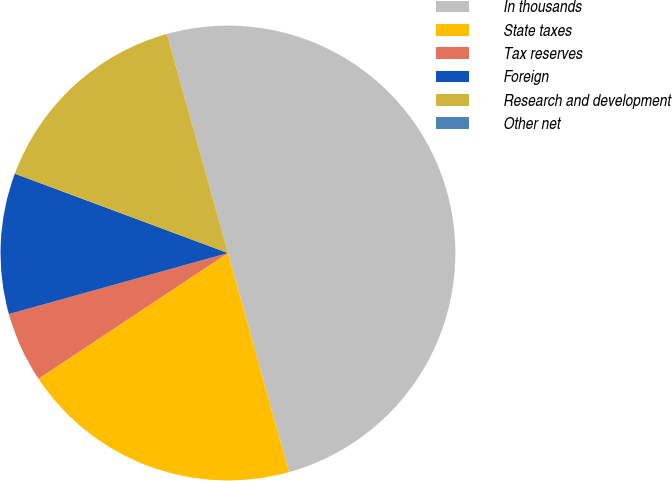Convert chart. <chart><loc_0><loc_0><loc_500><loc_500><pie_chart><fcel>In thousands<fcel>State taxes<fcel>Tax reserves<fcel>Foreign<fcel>Research and development<fcel>Other net<nl><fcel>50.0%<fcel>20.0%<fcel>5.0%<fcel>10.0%<fcel>15.0%<fcel>0.0%<nl></chart> 